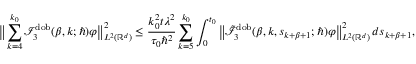Convert formula to latex. <formula><loc_0><loc_0><loc_500><loc_500>\left \| \sum _ { k = 4 } ^ { k _ { 0 } } \mathcal { I } _ { 3 } ^ { d o b } ( \beta , k ; \hbar { ) } \varphi \right \| _ { L ^ { 2 } ( \mathbb { R } ^ { d } ) } ^ { 2 } \leq \frac { k _ { 0 } ^ { 2 } t \lambda ^ { 2 } } { \tau _ { 0 } \hbar { ^ } { 2 } } \sum _ { k = 5 } ^ { k _ { 0 } } \int _ { 0 } ^ { t _ { 0 } } \left \| \tilde { \mathcal { I } } _ { 3 } ^ { d o b } ( \beta , k , s _ { k + \beta + 1 } ; \hbar { ) } \varphi \right \| _ { L ^ { 2 } ( \mathbb { R } ^ { d } ) } ^ { 2 } \, d s _ { k + \beta + 1 } ,</formula> 